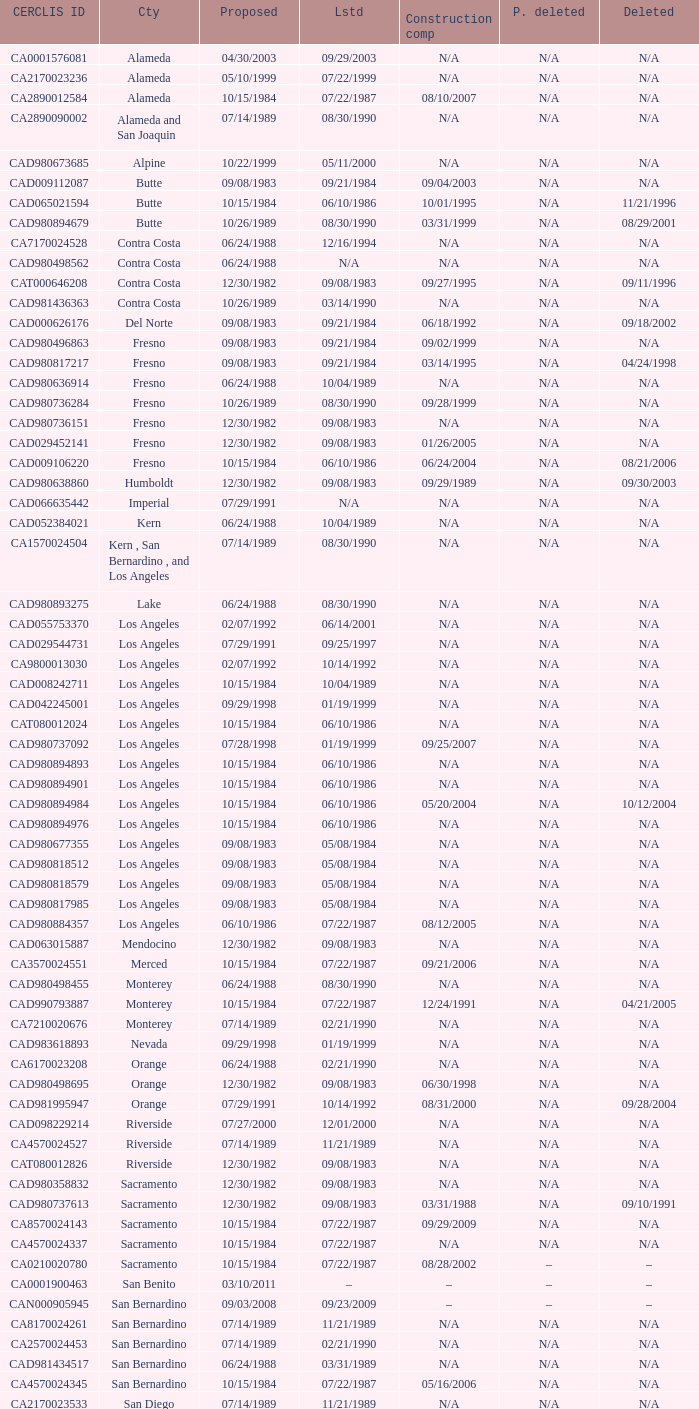What construction completed on 08/10/2007? 07/22/1987. 